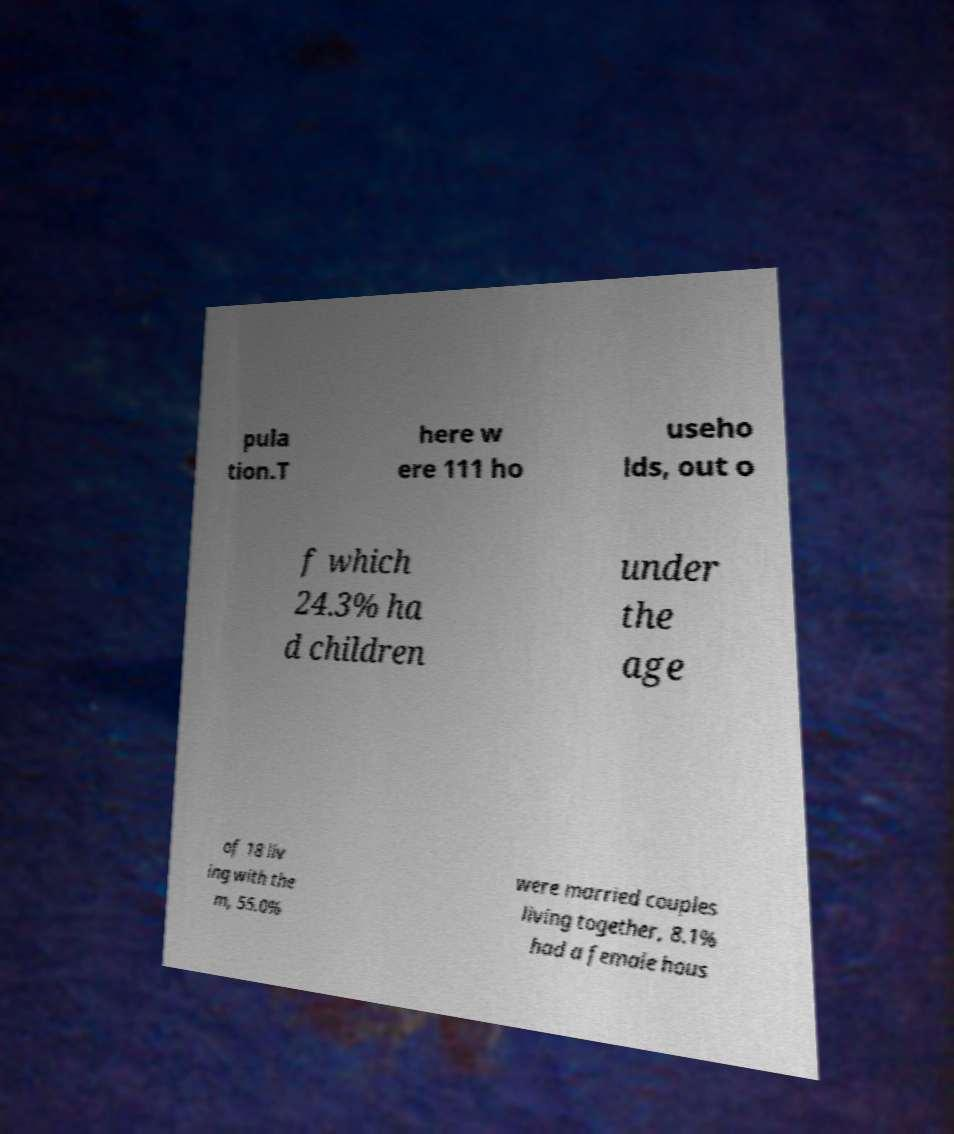Could you assist in decoding the text presented in this image and type it out clearly? pula tion.T here w ere 111 ho useho lds, out o f which 24.3% ha d children under the age of 18 liv ing with the m, 55.0% were married couples living together, 8.1% had a female hous 